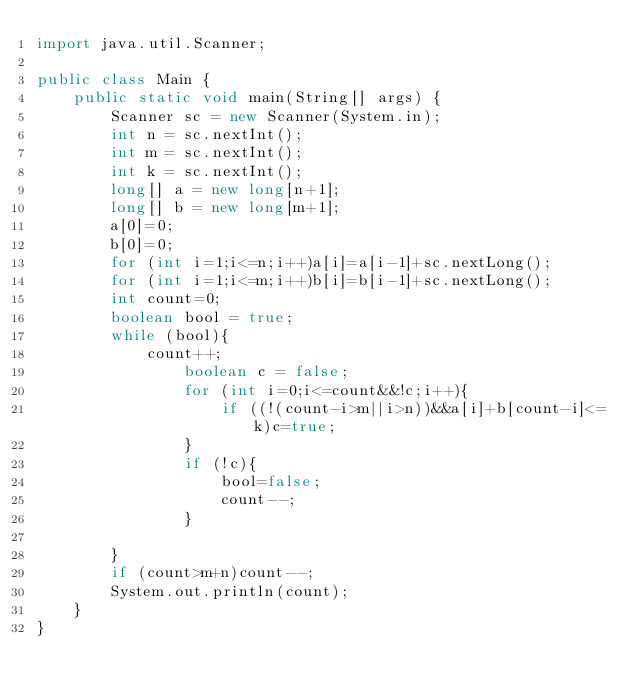Convert code to text. <code><loc_0><loc_0><loc_500><loc_500><_Java_>import java.util.Scanner;

public class Main {
    public static void main(String[] args) {
        Scanner sc = new Scanner(System.in);
        int n = sc.nextInt();
        int m = sc.nextInt();
        int k = sc.nextInt();
        long[] a = new long[n+1];
        long[] b = new long[m+1];
        a[0]=0;
        b[0]=0;
        for (int i=1;i<=n;i++)a[i]=a[i-1]+sc.nextLong();
        for (int i=1;i<=m;i++)b[i]=b[i-1]+sc.nextLong();
        int count=0;
        boolean bool = true;
        while (bool){
            count++;
                boolean c = false;
                for (int i=0;i<=count&&!c;i++){
                    if ((!(count-i>m||i>n))&&a[i]+b[count-i]<=k)c=true;
                }
                if (!c){
                    bool=false;
                    count--;
                }

        }
        if (count>m+n)count--;
        System.out.println(count);
    }
}
</code> 